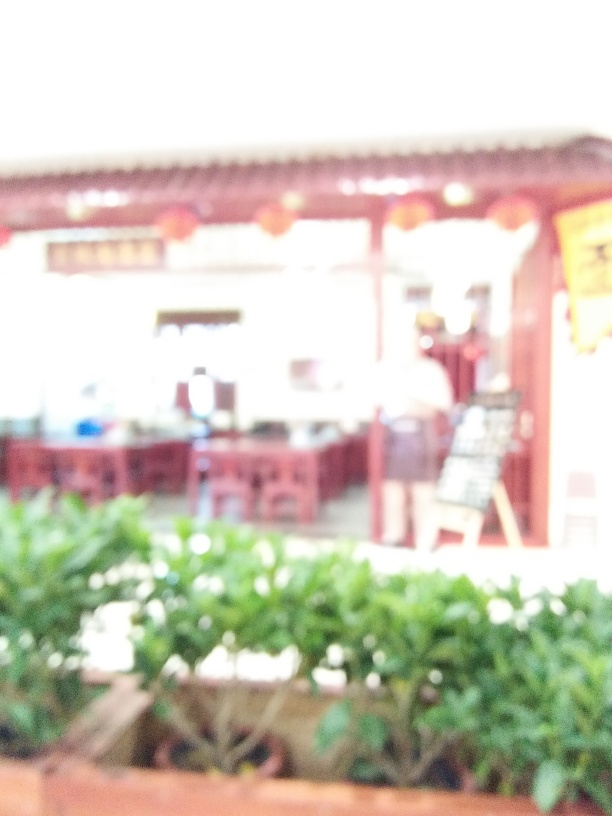What type of setting does this image suggest? The blurred shapes and structures suggest an open-air setting that could be a street or marketplace with some plants visible in the foreground, indicating a semi-urban environment. 